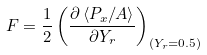Convert formula to latex. <formula><loc_0><loc_0><loc_500><loc_500>F = \frac { 1 } { 2 } \left ( \frac { \partial \left < P _ { x } / A \right > } { \partial Y _ { r } } \right ) _ { ( Y _ { r } = 0 . 5 ) }</formula> 